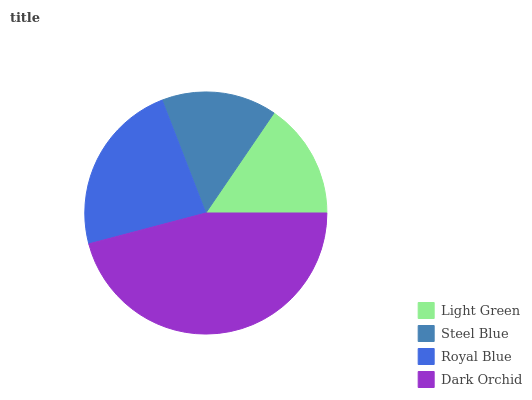Is Steel Blue the minimum?
Answer yes or no. Yes. Is Dark Orchid the maximum?
Answer yes or no. Yes. Is Royal Blue the minimum?
Answer yes or no. No. Is Royal Blue the maximum?
Answer yes or no. No. Is Royal Blue greater than Steel Blue?
Answer yes or no. Yes. Is Steel Blue less than Royal Blue?
Answer yes or no. Yes. Is Steel Blue greater than Royal Blue?
Answer yes or no. No. Is Royal Blue less than Steel Blue?
Answer yes or no. No. Is Royal Blue the high median?
Answer yes or no. Yes. Is Light Green the low median?
Answer yes or no. Yes. Is Dark Orchid the high median?
Answer yes or no. No. Is Steel Blue the low median?
Answer yes or no. No. 